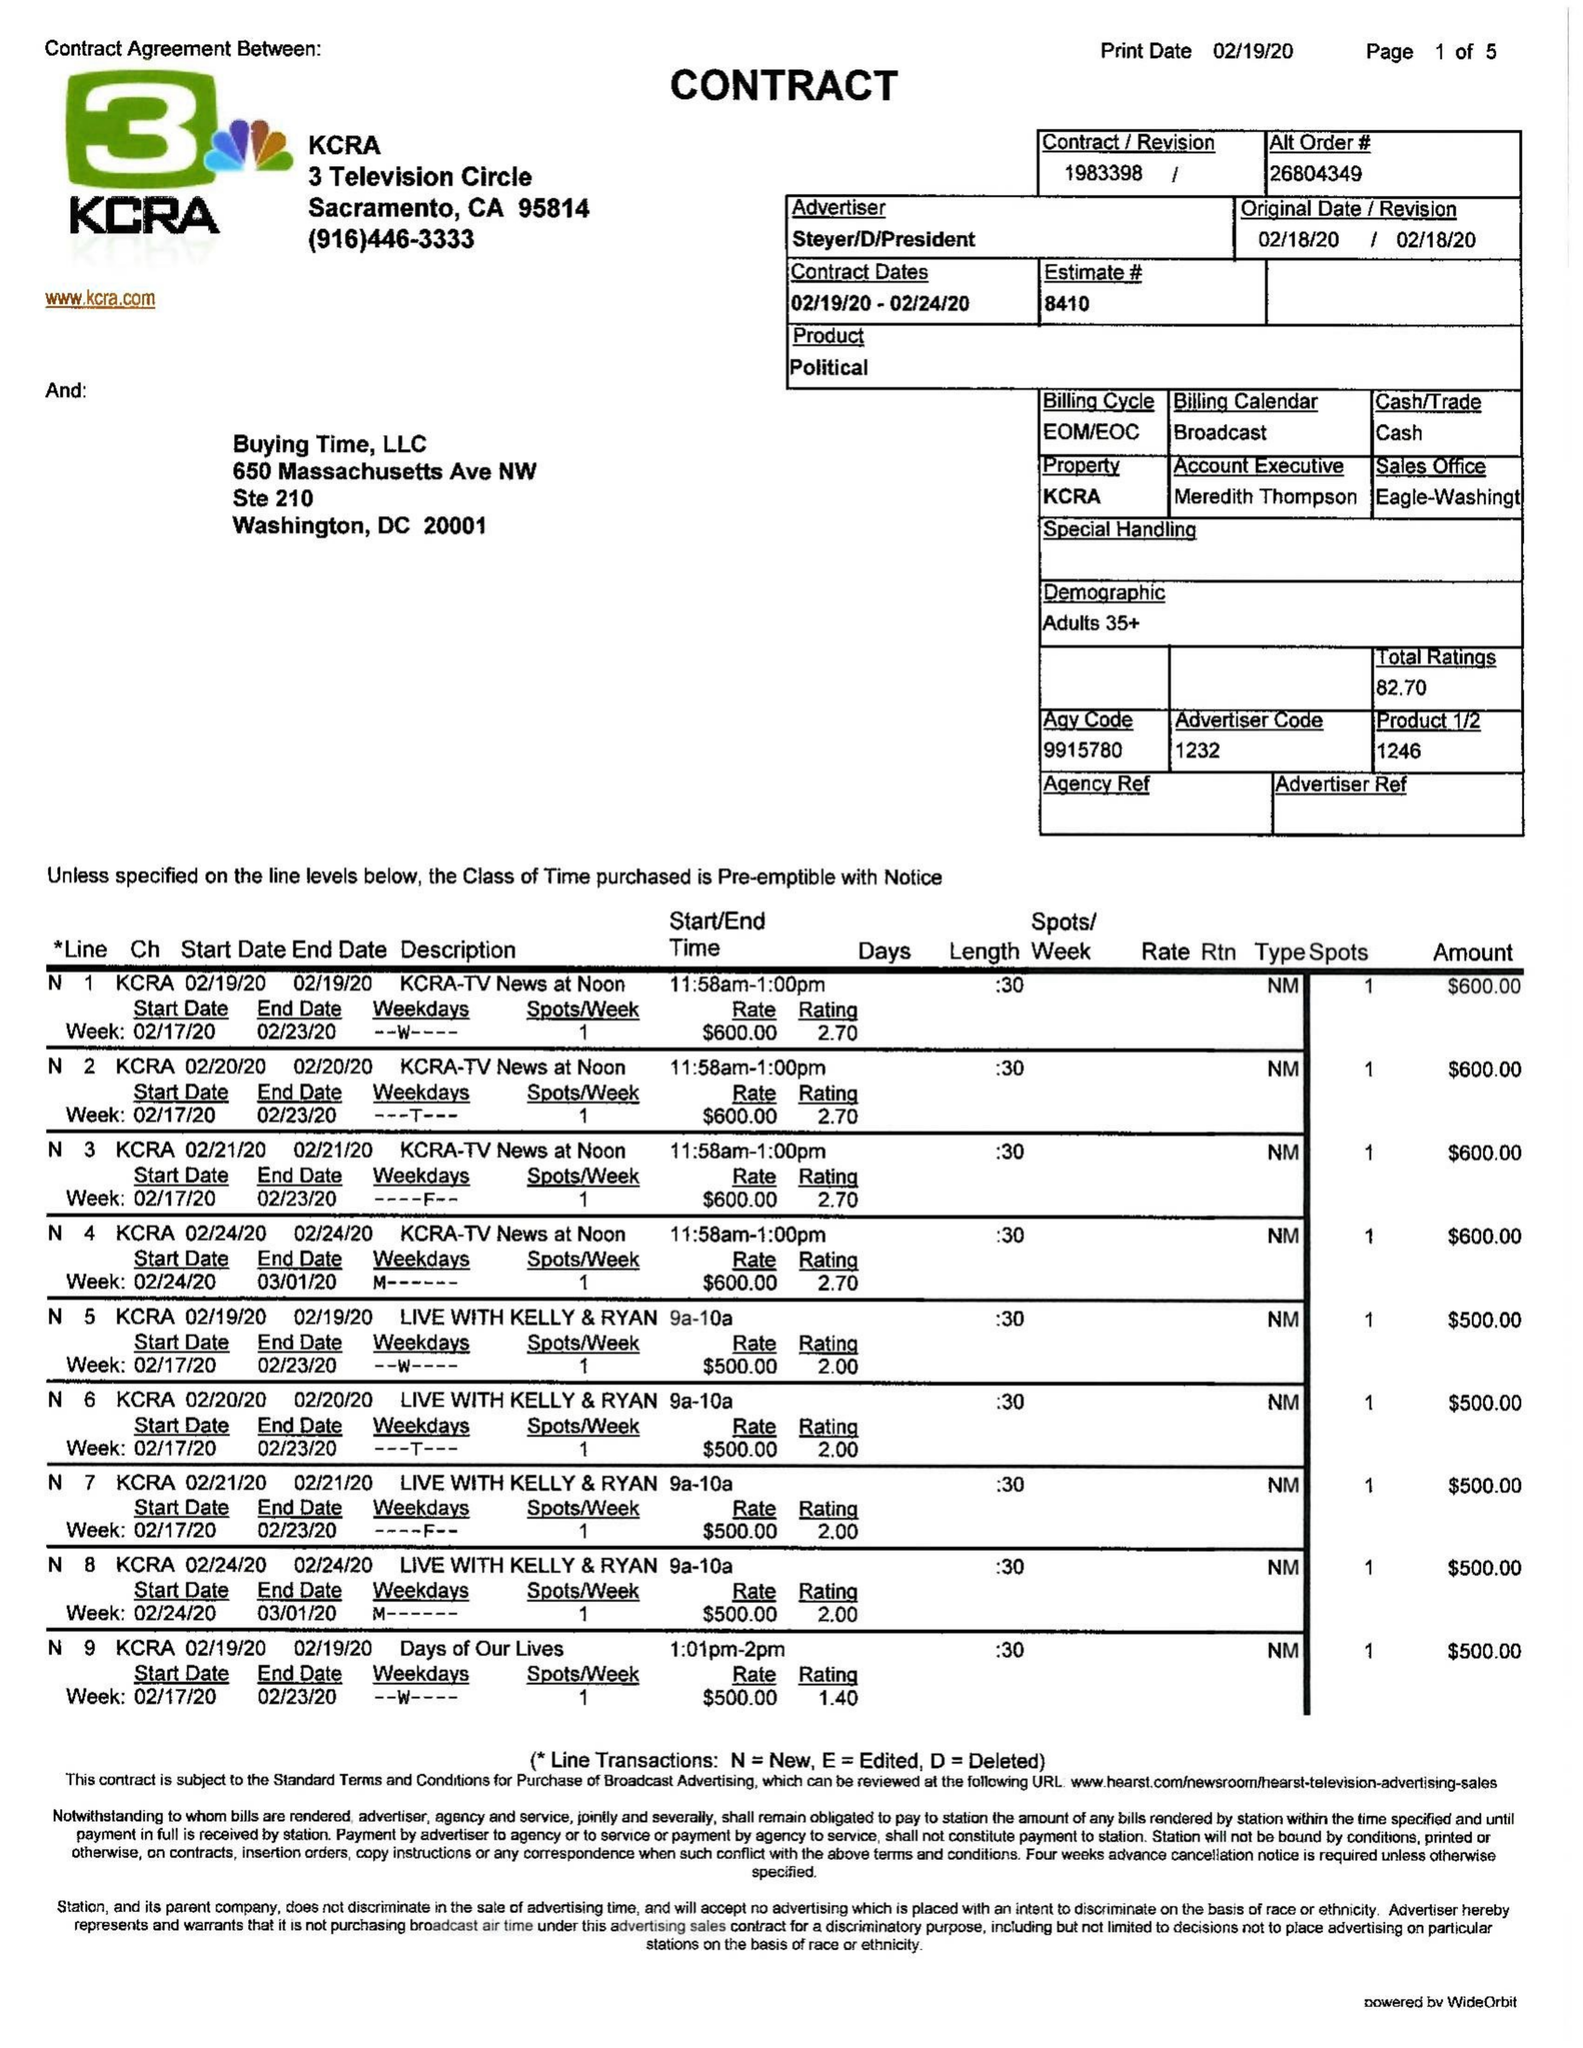What is the value for the advertiser?
Answer the question using a single word or phrase. STEYER/D/PRESIDENT 